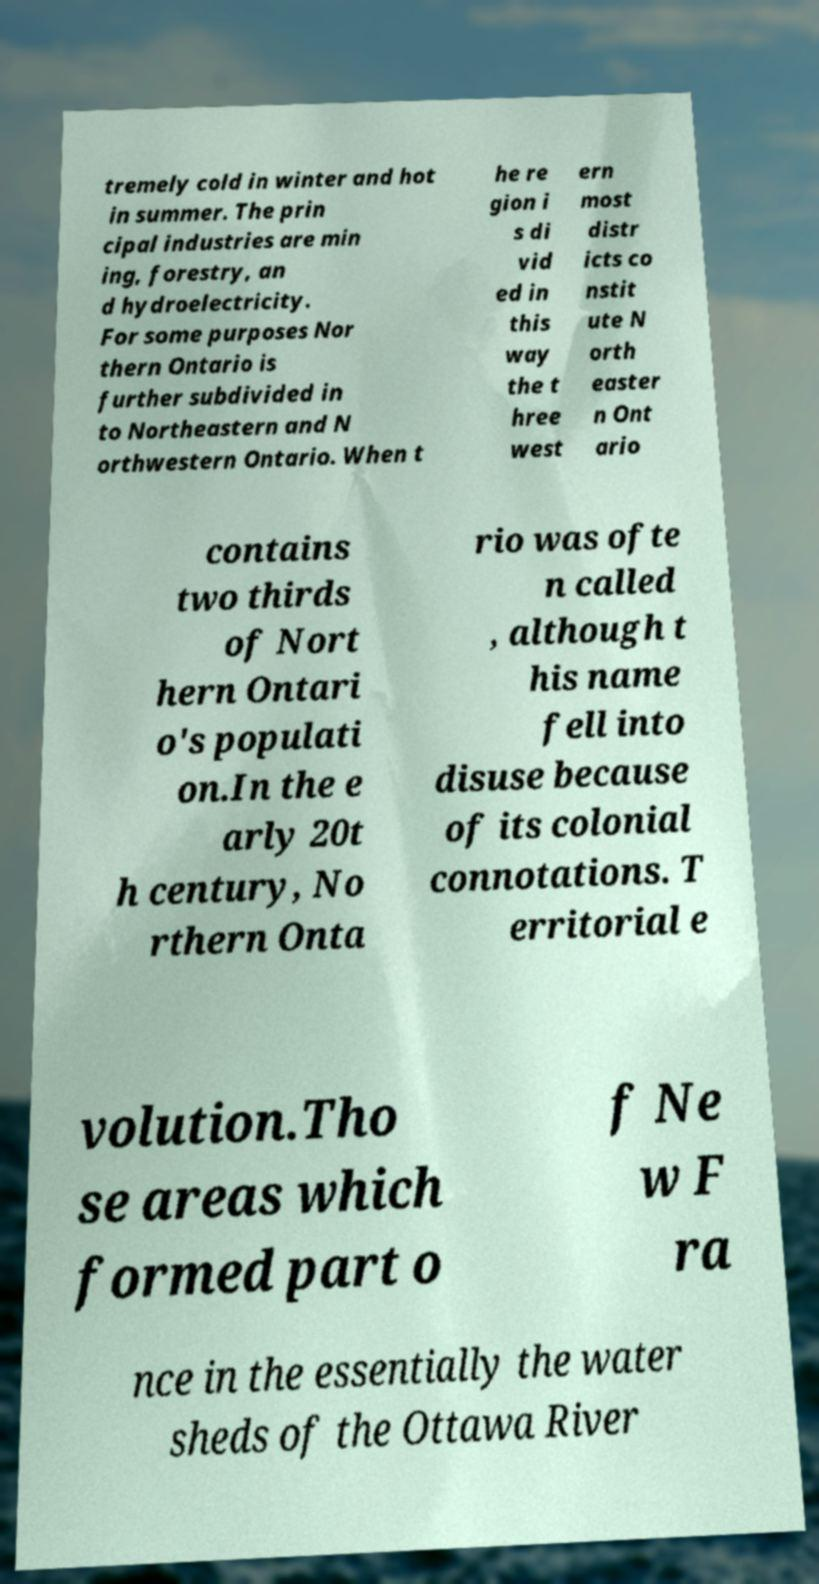Please read and relay the text visible in this image. What does it say? tremely cold in winter and hot in summer. The prin cipal industries are min ing, forestry, an d hydroelectricity. For some purposes Nor thern Ontario is further subdivided in to Northeastern and N orthwestern Ontario. When t he re gion i s di vid ed in this way the t hree west ern most distr icts co nstit ute N orth easter n Ont ario contains two thirds of Nort hern Ontari o's populati on.In the e arly 20t h century, No rthern Onta rio was ofte n called , although t his name fell into disuse because of its colonial connotations. T erritorial e volution.Tho se areas which formed part o f Ne w F ra nce in the essentially the water sheds of the Ottawa River 